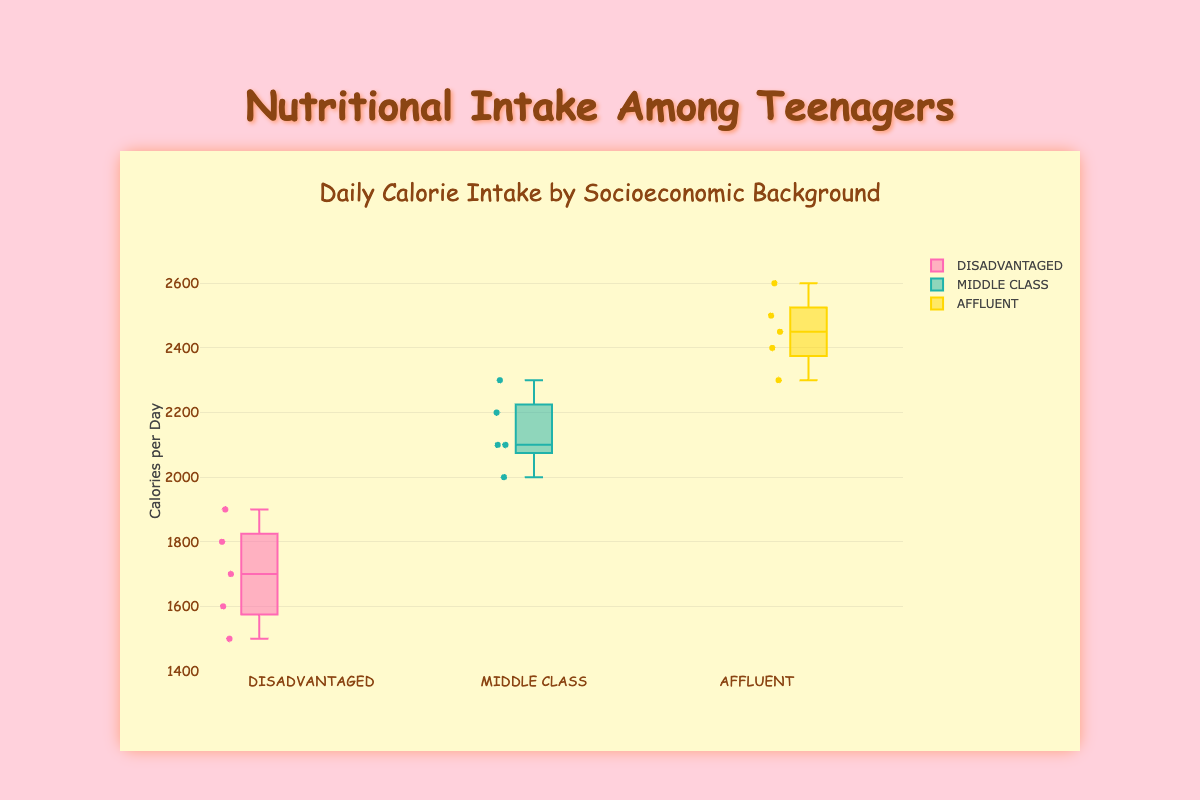Does the median calorie intake differ significantly between groups? To find out whether the median calorie intake differs, look at the middle line inside each box, which represents the median. Compare the positions of these lines across the three groups to see if there are noticeable differences.
Answer: Yes, they differ What is the range of calorie intake for the disadvantaged group? The range is found by subtracting the minimum value (represented by the bottom whisker) from the maximum value (represented by the top whisker) for the disadvantaged group. In this case, it is 1900 - 1500.
Answer: 400 calories Which group has the highest median calorie intake? The median is represented by the horizontal line inside each box. Compare these medians across the three groups. The affluent group has the highest median.
Answer: Affluent What is the interquartile range (IQR) for the middle class group? The IQR is calculated by subtracting the 25th percentile (bottom of the box) from the 75th percentile (top of the box). For the middle-class group, estimate these values from the plot.
Answer: Approximately 200 calories Which socioeconomic group has the most variable calorie intake? Variability can be assessed by the length of the box and the whiskers. Longer boxes and whiskers indicate more variability.
Answer: Affluent Are there any outliers in the data? Outliers are data points that fall outside the whiskers. Look for any points that are outside the lines extending from the boxes.
Answer: No Between which two groups is the discrepancy in average calorie intake the largest? To find the discrepancy in average calorie intake, visually estimate the averages by looking at the distribution of points within each box. Calculate the differences between the averages for each pair.
Answer: Disadvantaged and Affluent Does the box for the middle class group overlap with the box for the affluent group? Overlap can be visualized directly by checking if the boxes for these socioeconomic backgrounds intercept.
Answer: Yes, they overlap What's the highest calorie intake recorded in the disadvantaged group? The highest value in a box plot is represented by the top whisker. For the disadvantaged group, identify this top whisker.
Answer: 1900 calories 